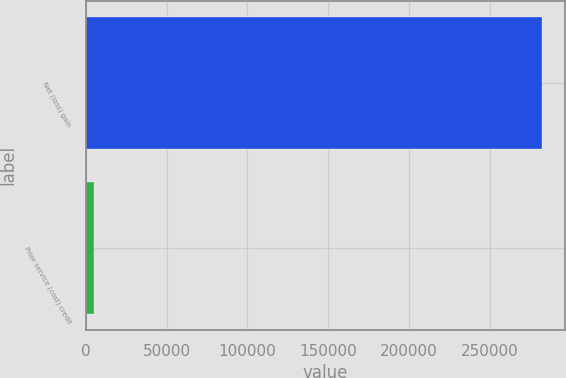Convert chart to OTSL. <chart><loc_0><loc_0><loc_500><loc_500><bar_chart><fcel>Net (loss) gain<fcel>Prior service (cost) credit<nl><fcel>282491<fcel>4975<nl></chart> 